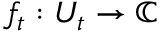Convert formula to latex. <formula><loc_0><loc_0><loc_500><loc_500>f _ { t } \colon U _ { t } \to \mathbb { C }</formula> 